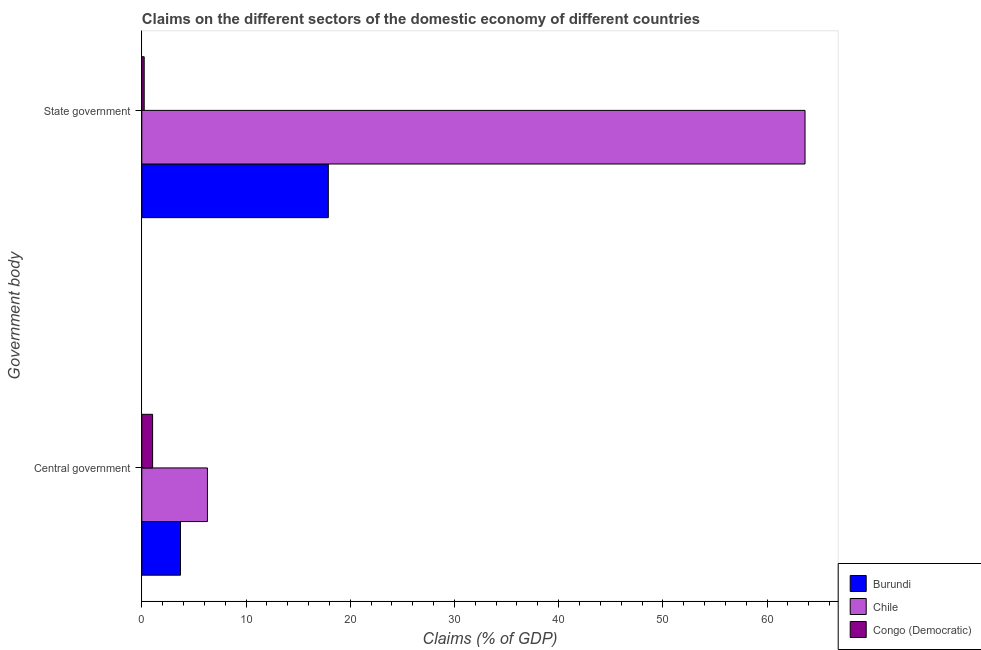How many different coloured bars are there?
Give a very brief answer. 3. Are the number of bars per tick equal to the number of legend labels?
Your answer should be very brief. Yes. How many bars are there on the 2nd tick from the top?
Offer a very short reply. 3. What is the label of the 2nd group of bars from the top?
Ensure brevity in your answer.  Central government. What is the claims on state government in Chile?
Provide a short and direct response. 63.64. Across all countries, what is the maximum claims on central government?
Ensure brevity in your answer.  6.3. Across all countries, what is the minimum claims on state government?
Make the answer very short. 0.23. In which country was the claims on central government minimum?
Ensure brevity in your answer.  Congo (Democratic). What is the total claims on state government in the graph?
Offer a very short reply. 81.77. What is the difference between the claims on central government in Burundi and that in Congo (Democratic)?
Your answer should be very brief. 2.67. What is the difference between the claims on state government in Congo (Democratic) and the claims on central government in Burundi?
Your response must be concise. -3.48. What is the average claims on state government per country?
Offer a terse response. 27.26. What is the difference between the claims on central government and claims on state government in Burundi?
Provide a succinct answer. -14.19. In how many countries, is the claims on central government greater than 32 %?
Provide a succinct answer. 0. What is the ratio of the claims on state government in Burundi to that in Congo (Democratic)?
Offer a very short reply. 77.73. Is the claims on central government in Congo (Democratic) less than that in Burundi?
Ensure brevity in your answer.  Yes. What does the 3rd bar from the top in State government represents?
Make the answer very short. Burundi. What does the 3rd bar from the bottom in State government represents?
Your answer should be very brief. Congo (Democratic). How many bars are there?
Offer a terse response. 6. Are all the bars in the graph horizontal?
Provide a short and direct response. Yes. What is the difference between two consecutive major ticks on the X-axis?
Provide a short and direct response. 10. Are the values on the major ticks of X-axis written in scientific E-notation?
Provide a short and direct response. No. Does the graph contain any zero values?
Provide a short and direct response. No. Where does the legend appear in the graph?
Your answer should be very brief. Bottom right. How many legend labels are there?
Make the answer very short. 3. What is the title of the graph?
Give a very brief answer. Claims on the different sectors of the domestic economy of different countries. What is the label or title of the X-axis?
Provide a short and direct response. Claims (% of GDP). What is the label or title of the Y-axis?
Make the answer very short. Government body. What is the Claims (% of GDP) in Burundi in Central government?
Offer a very short reply. 3.71. What is the Claims (% of GDP) in Chile in Central government?
Give a very brief answer. 6.3. What is the Claims (% of GDP) of Congo (Democratic) in Central government?
Offer a terse response. 1.04. What is the Claims (% of GDP) of Burundi in State government?
Provide a short and direct response. 17.9. What is the Claims (% of GDP) of Chile in State government?
Your answer should be very brief. 63.64. What is the Claims (% of GDP) in Congo (Democratic) in State government?
Provide a short and direct response. 0.23. Across all Government body, what is the maximum Claims (% of GDP) of Burundi?
Keep it short and to the point. 17.9. Across all Government body, what is the maximum Claims (% of GDP) in Chile?
Offer a terse response. 63.64. Across all Government body, what is the maximum Claims (% of GDP) in Congo (Democratic)?
Offer a terse response. 1.04. Across all Government body, what is the minimum Claims (% of GDP) of Burundi?
Give a very brief answer. 3.71. Across all Government body, what is the minimum Claims (% of GDP) in Chile?
Provide a succinct answer. 6.3. Across all Government body, what is the minimum Claims (% of GDP) of Congo (Democratic)?
Offer a terse response. 0.23. What is the total Claims (% of GDP) in Burundi in the graph?
Offer a very short reply. 21.61. What is the total Claims (% of GDP) in Chile in the graph?
Offer a terse response. 69.94. What is the total Claims (% of GDP) in Congo (Democratic) in the graph?
Provide a short and direct response. 1.27. What is the difference between the Claims (% of GDP) of Burundi in Central government and that in State government?
Your response must be concise. -14.19. What is the difference between the Claims (% of GDP) in Chile in Central government and that in State government?
Your response must be concise. -57.34. What is the difference between the Claims (% of GDP) in Congo (Democratic) in Central government and that in State government?
Give a very brief answer. 0.81. What is the difference between the Claims (% of GDP) in Burundi in Central government and the Claims (% of GDP) in Chile in State government?
Make the answer very short. -59.93. What is the difference between the Claims (% of GDP) in Burundi in Central government and the Claims (% of GDP) in Congo (Democratic) in State government?
Your answer should be compact. 3.48. What is the difference between the Claims (% of GDP) of Chile in Central government and the Claims (% of GDP) of Congo (Democratic) in State government?
Your response must be concise. 6.07. What is the average Claims (% of GDP) in Burundi per Government body?
Give a very brief answer. 10.81. What is the average Claims (% of GDP) of Chile per Government body?
Keep it short and to the point. 34.97. What is the average Claims (% of GDP) of Congo (Democratic) per Government body?
Ensure brevity in your answer.  0.63. What is the difference between the Claims (% of GDP) of Burundi and Claims (% of GDP) of Chile in Central government?
Ensure brevity in your answer.  -2.59. What is the difference between the Claims (% of GDP) of Burundi and Claims (% of GDP) of Congo (Democratic) in Central government?
Provide a succinct answer. 2.67. What is the difference between the Claims (% of GDP) in Chile and Claims (% of GDP) in Congo (Democratic) in Central government?
Your answer should be compact. 5.26. What is the difference between the Claims (% of GDP) of Burundi and Claims (% of GDP) of Chile in State government?
Offer a terse response. -45.74. What is the difference between the Claims (% of GDP) of Burundi and Claims (% of GDP) of Congo (Democratic) in State government?
Your answer should be very brief. 17.67. What is the difference between the Claims (% of GDP) of Chile and Claims (% of GDP) of Congo (Democratic) in State government?
Provide a succinct answer. 63.41. What is the ratio of the Claims (% of GDP) of Burundi in Central government to that in State government?
Offer a very short reply. 0.21. What is the ratio of the Claims (% of GDP) in Chile in Central government to that in State government?
Your answer should be compact. 0.1. What is the ratio of the Claims (% of GDP) in Congo (Democratic) in Central government to that in State government?
Make the answer very short. 4.51. What is the difference between the highest and the second highest Claims (% of GDP) of Burundi?
Provide a succinct answer. 14.19. What is the difference between the highest and the second highest Claims (% of GDP) of Chile?
Provide a succinct answer. 57.34. What is the difference between the highest and the second highest Claims (% of GDP) in Congo (Democratic)?
Ensure brevity in your answer.  0.81. What is the difference between the highest and the lowest Claims (% of GDP) of Burundi?
Your response must be concise. 14.19. What is the difference between the highest and the lowest Claims (% of GDP) of Chile?
Ensure brevity in your answer.  57.34. What is the difference between the highest and the lowest Claims (% of GDP) of Congo (Democratic)?
Make the answer very short. 0.81. 